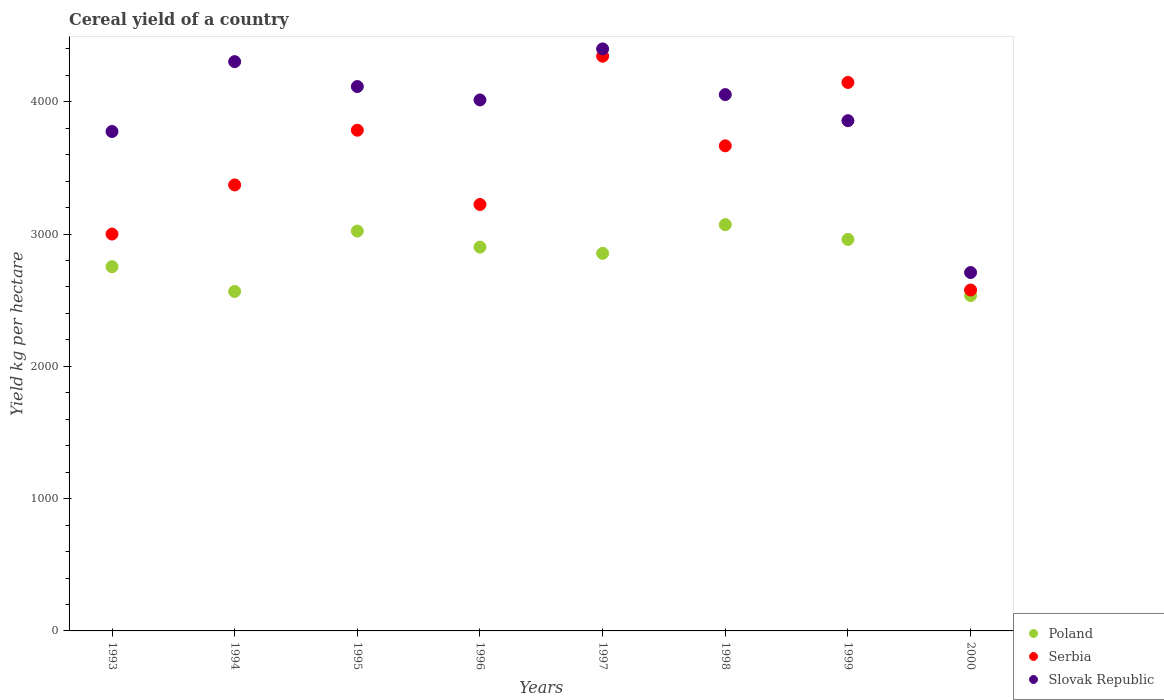How many different coloured dotlines are there?
Ensure brevity in your answer.  3. What is the total cereal yield in Poland in 1994?
Offer a terse response. 2566.15. Across all years, what is the maximum total cereal yield in Poland?
Provide a succinct answer. 3070.96. Across all years, what is the minimum total cereal yield in Serbia?
Your answer should be very brief. 2576.82. In which year was the total cereal yield in Poland maximum?
Your answer should be compact. 1998. In which year was the total cereal yield in Serbia minimum?
Provide a succinct answer. 2000. What is the total total cereal yield in Slovak Republic in the graph?
Your answer should be very brief. 3.12e+04. What is the difference between the total cereal yield in Slovak Republic in 1996 and that in 1998?
Provide a succinct answer. -40.36. What is the difference between the total cereal yield in Poland in 1993 and the total cereal yield in Serbia in 1995?
Offer a very short reply. -1031.81. What is the average total cereal yield in Serbia per year?
Give a very brief answer. 3514.04. In the year 1999, what is the difference between the total cereal yield in Slovak Republic and total cereal yield in Poland?
Keep it short and to the point. 897.32. What is the ratio of the total cereal yield in Slovak Republic in 1998 to that in 1999?
Ensure brevity in your answer.  1.05. Is the difference between the total cereal yield in Slovak Republic in 1993 and 2000 greater than the difference between the total cereal yield in Poland in 1993 and 2000?
Keep it short and to the point. Yes. What is the difference between the highest and the second highest total cereal yield in Serbia?
Make the answer very short. 198.02. What is the difference between the highest and the lowest total cereal yield in Slovak Republic?
Keep it short and to the point. 1690.08. Is the sum of the total cereal yield in Poland in 1995 and 1999 greater than the maximum total cereal yield in Serbia across all years?
Offer a very short reply. Yes. Is the total cereal yield in Serbia strictly less than the total cereal yield in Slovak Republic over the years?
Ensure brevity in your answer.  No. How many years are there in the graph?
Provide a short and direct response. 8. Does the graph contain any zero values?
Provide a succinct answer. No. What is the title of the graph?
Make the answer very short. Cereal yield of a country. What is the label or title of the X-axis?
Your answer should be very brief. Years. What is the label or title of the Y-axis?
Make the answer very short. Yield kg per hectare. What is the Yield kg per hectare in Poland in 1993?
Keep it short and to the point. 2752.95. What is the Yield kg per hectare of Serbia in 1993?
Your answer should be compact. 2999.79. What is the Yield kg per hectare of Slovak Republic in 1993?
Make the answer very short. 3774.97. What is the Yield kg per hectare in Poland in 1994?
Your answer should be compact. 2566.15. What is the Yield kg per hectare in Serbia in 1994?
Your response must be concise. 3371.02. What is the Yield kg per hectare of Slovak Republic in 1994?
Your response must be concise. 4302.99. What is the Yield kg per hectare in Poland in 1995?
Make the answer very short. 3022.36. What is the Yield kg per hectare in Serbia in 1995?
Make the answer very short. 3784.76. What is the Yield kg per hectare in Slovak Republic in 1995?
Keep it short and to the point. 4114.81. What is the Yield kg per hectare in Poland in 1996?
Provide a short and direct response. 2901.09. What is the Yield kg per hectare of Serbia in 1996?
Provide a succinct answer. 3223.3. What is the Yield kg per hectare of Slovak Republic in 1996?
Offer a very short reply. 4013.58. What is the Yield kg per hectare in Poland in 1997?
Keep it short and to the point. 2854.06. What is the Yield kg per hectare in Serbia in 1997?
Ensure brevity in your answer.  4343.93. What is the Yield kg per hectare of Slovak Republic in 1997?
Your response must be concise. 4399.25. What is the Yield kg per hectare in Poland in 1998?
Offer a terse response. 3070.96. What is the Yield kg per hectare of Serbia in 1998?
Offer a very short reply. 3666.8. What is the Yield kg per hectare in Slovak Republic in 1998?
Provide a short and direct response. 4053.93. What is the Yield kg per hectare of Poland in 1999?
Provide a succinct answer. 2959.36. What is the Yield kg per hectare in Serbia in 1999?
Offer a very short reply. 4145.9. What is the Yield kg per hectare in Slovak Republic in 1999?
Offer a very short reply. 3856.68. What is the Yield kg per hectare of Poland in 2000?
Ensure brevity in your answer.  2534.78. What is the Yield kg per hectare of Serbia in 2000?
Your response must be concise. 2576.82. What is the Yield kg per hectare in Slovak Republic in 2000?
Ensure brevity in your answer.  2709.16. Across all years, what is the maximum Yield kg per hectare of Poland?
Provide a short and direct response. 3070.96. Across all years, what is the maximum Yield kg per hectare in Serbia?
Your answer should be very brief. 4343.93. Across all years, what is the maximum Yield kg per hectare in Slovak Republic?
Provide a short and direct response. 4399.25. Across all years, what is the minimum Yield kg per hectare of Poland?
Provide a short and direct response. 2534.78. Across all years, what is the minimum Yield kg per hectare of Serbia?
Offer a terse response. 2576.82. Across all years, what is the minimum Yield kg per hectare of Slovak Republic?
Offer a terse response. 2709.16. What is the total Yield kg per hectare of Poland in the graph?
Your answer should be very brief. 2.27e+04. What is the total Yield kg per hectare in Serbia in the graph?
Make the answer very short. 2.81e+04. What is the total Yield kg per hectare in Slovak Republic in the graph?
Provide a succinct answer. 3.12e+04. What is the difference between the Yield kg per hectare of Poland in 1993 and that in 1994?
Your answer should be compact. 186.81. What is the difference between the Yield kg per hectare of Serbia in 1993 and that in 1994?
Offer a very short reply. -371.23. What is the difference between the Yield kg per hectare of Slovak Republic in 1993 and that in 1994?
Your answer should be very brief. -528.02. What is the difference between the Yield kg per hectare of Poland in 1993 and that in 1995?
Offer a very short reply. -269.41. What is the difference between the Yield kg per hectare in Serbia in 1993 and that in 1995?
Provide a short and direct response. -784.98. What is the difference between the Yield kg per hectare in Slovak Republic in 1993 and that in 1995?
Keep it short and to the point. -339.83. What is the difference between the Yield kg per hectare in Poland in 1993 and that in 1996?
Keep it short and to the point. -148.14. What is the difference between the Yield kg per hectare in Serbia in 1993 and that in 1996?
Your answer should be very brief. -223.51. What is the difference between the Yield kg per hectare in Slovak Republic in 1993 and that in 1996?
Keep it short and to the point. -238.6. What is the difference between the Yield kg per hectare of Poland in 1993 and that in 1997?
Provide a succinct answer. -101.11. What is the difference between the Yield kg per hectare of Serbia in 1993 and that in 1997?
Provide a succinct answer. -1344.14. What is the difference between the Yield kg per hectare in Slovak Republic in 1993 and that in 1997?
Make the answer very short. -624.27. What is the difference between the Yield kg per hectare of Poland in 1993 and that in 1998?
Offer a terse response. -318.01. What is the difference between the Yield kg per hectare in Serbia in 1993 and that in 1998?
Provide a short and direct response. -667.01. What is the difference between the Yield kg per hectare of Slovak Republic in 1993 and that in 1998?
Provide a short and direct response. -278.96. What is the difference between the Yield kg per hectare of Poland in 1993 and that in 1999?
Offer a very short reply. -206.41. What is the difference between the Yield kg per hectare of Serbia in 1993 and that in 1999?
Your response must be concise. -1146.12. What is the difference between the Yield kg per hectare in Slovak Republic in 1993 and that in 1999?
Offer a terse response. -81.71. What is the difference between the Yield kg per hectare in Poland in 1993 and that in 2000?
Ensure brevity in your answer.  218.17. What is the difference between the Yield kg per hectare of Serbia in 1993 and that in 2000?
Your answer should be compact. 422.96. What is the difference between the Yield kg per hectare in Slovak Republic in 1993 and that in 2000?
Keep it short and to the point. 1065.81. What is the difference between the Yield kg per hectare in Poland in 1994 and that in 1995?
Offer a terse response. -456.21. What is the difference between the Yield kg per hectare of Serbia in 1994 and that in 1995?
Make the answer very short. -413.74. What is the difference between the Yield kg per hectare in Slovak Republic in 1994 and that in 1995?
Your answer should be compact. 188.18. What is the difference between the Yield kg per hectare of Poland in 1994 and that in 1996?
Offer a terse response. -334.94. What is the difference between the Yield kg per hectare of Serbia in 1994 and that in 1996?
Offer a very short reply. 147.72. What is the difference between the Yield kg per hectare of Slovak Republic in 1994 and that in 1996?
Make the answer very short. 289.41. What is the difference between the Yield kg per hectare in Poland in 1994 and that in 1997?
Ensure brevity in your answer.  -287.92. What is the difference between the Yield kg per hectare in Serbia in 1994 and that in 1997?
Provide a succinct answer. -972.9. What is the difference between the Yield kg per hectare in Slovak Republic in 1994 and that in 1997?
Your answer should be compact. -96.26. What is the difference between the Yield kg per hectare of Poland in 1994 and that in 1998?
Keep it short and to the point. -504.81. What is the difference between the Yield kg per hectare in Serbia in 1994 and that in 1998?
Your response must be concise. -295.78. What is the difference between the Yield kg per hectare of Slovak Republic in 1994 and that in 1998?
Offer a terse response. 249.06. What is the difference between the Yield kg per hectare in Poland in 1994 and that in 1999?
Provide a short and direct response. -393.22. What is the difference between the Yield kg per hectare of Serbia in 1994 and that in 1999?
Offer a terse response. -774.88. What is the difference between the Yield kg per hectare in Slovak Republic in 1994 and that in 1999?
Your response must be concise. 446.31. What is the difference between the Yield kg per hectare of Poland in 1994 and that in 2000?
Your answer should be very brief. 31.37. What is the difference between the Yield kg per hectare of Serbia in 1994 and that in 2000?
Give a very brief answer. 794.2. What is the difference between the Yield kg per hectare in Slovak Republic in 1994 and that in 2000?
Make the answer very short. 1593.83. What is the difference between the Yield kg per hectare in Poland in 1995 and that in 1996?
Provide a succinct answer. 121.27. What is the difference between the Yield kg per hectare of Serbia in 1995 and that in 1996?
Ensure brevity in your answer.  561.46. What is the difference between the Yield kg per hectare in Slovak Republic in 1995 and that in 1996?
Provide a succinct answer. 101.23. What is the difference between the Yield kg per hectare of Poland in 1995 and that in 1997?
Your answer should be very brief. 168.3. What is the difference between the Yield kg per hectare of Serbia in 1995 and that in 1997?
Offer a very short reply. -559.16. What is the difference between the Yield kg per hectare of Slovak Republic in 1995 and that in 1997?
Offer a very short reply. -284.44. What is the difference between the Yield kg per hectare of Poland in 1995 and that in 1998?
Give a very brief answer. -48.6. What is the difference between the Yield kg per hectare of Serbia in 1995 and that in 1998?
Your response must be concise. 117.96. What is the difference between the Yield kg per hectare of Slovak Republic in 1995 and that in 1998?
Your response must be concise. 60.87. What is the difference between the Yield kg per hectare in Poland in 1995 and that in 1999?
Your answer should be very brief. 63. What is the difference between the Yield kg per hectare of Serbia in 1995 and that in 1999?
Your answer should be very brief. -361.14. What is the difference between the Yield kg per hectare of Slovak Republic in 1995 and that in 1999?
Your response must be concise. 258.13. What is the difference between the Yield kg per hectare in Poland in 1995 and that in 2000?
Your answer should be compact. 487.58. What is the difference between the Yield kg per hectare of Serbia in 1995 and that in 2000?
Offer a very short reply. 1207.94. What is the difference between the Yield kg per hectare in Slovak Republic in 1995 and that in 2000?
Ensure brevity in your answer.  1405.64. What is the difference between the Yield kg per hectare in Poland in 1996 and that in 1997?
Offer a very short reply. 47.03. What is the difference between the Yield kg per hectare of Serbia in 1996 and that in 1997?
Your answer should be very brief. -1120.62. What is the difference between the Yield kg per hectare of Slovak Republic in 1996 and that in 1997?
Make the answer very short. -385.67. What is the difference between the Yield kg per hectare of Poland in 1996 and that in 1998?
Your response must be concise. -169.87. What is the difference between the Yield kg per hectare of Serbia in 1996 and that in 1998?
Make the answer very short. -443.5. What is the difference between the Yield kg per hectare of Slovak Republic in 1996 and that in 1998?
Your response must be concise. -40.36. What is the difference between the Yield kg per hectare of Poland in 1996 and that in 1999?
Give a very brief answer. -58.27. What is the difference between the Yield kg per hectare in Serbia in 1996 and that in 1999?
Give a very brief answer. -922.6. What is the difference between the Yield kg per hectare in Slovak Republic in 1996 and that in 1999?
Give a very brief answer. 156.9. What is the difference between the Yield kg per hectare of Poland in 1996 and that in 2000?
Offer a very short reply. 366.31. What is the difference between the Yield kg per hectare of Serbia in 1996 and that in 2000?
Ensure brevity in your answer.  646.48. What is the difference between the Yield kg per hectare in Slovak Republic in 1996 and that in 2000?
Make the answer very short. 1304.41. What is the difference between the Yield kg per hectare of Poland in 1997 and that in 1998?
Your response must be concise. -216.9. What is the difference between the Yield kg per hectare of Serbia in 1997 and that in 1998?
Offer a very short reply. 677.12. What is the difference between the Yield kg per hectare in Slovak Republic in 1997 and that in 1998?
Keep it short and to the point. 345.31. What is the difference between the Yield kg per hectare of Poland in 1997 and that in 1999?
Make the answer very short. -105.3. What is the difference between the Yield kg per hectare of Serbia in 1997 and that in 1999?
Make the answer very short. 198.02. What is the difference between the Yield kg per hectare in Slovak Republic in 1997 and that in 1999?
Give a very brief answer. 542.57. What is the difference between the Yield kg per hectare of Poland in 1997 and that in 2000?
Make the answer very short. 319.28. What is the difference between the Yield kg per hectare of Serbia in 1997 and that in 2000?
Offer a very short reply. 1767.1. What is the difference between the Yield kg per hectare in Slovak Republic in 1997 and that in 2000?
Your answer should be compact. 1690.08. What is the difference between the Yield kg per hectare in Poland in 1998 and that in 1999?
Ensure brevity in your answer.  111.6. What is the difference between the Yield kg per hectare of Serbia in 1998 and that in 1999?
Ensure brevity in your answer.  -479.1. What is the difference between the Yield kg per hectare of Slovak Republic in 1998 and that in 1999?
Your response must be concise. 197.25. What is the difference between the Yield kg per hectare of Poland in 1998 and that in 2000?
Your answer should be compact. 536.18. What is the difference between the Yield kg per hectare of Serbia in 1998 and that in 2000?
Make the answer very short. 1089.98. What is the difference between the Yield kg per hectare of Slovak Republic in 1998 and that in 2000?
Your answer should be compact. 1344.77. What is the difference between the Yield kg per hectare of Poland in 1999 and that in 2000?
Provide a succinct answer. 424.58. What is the difference between the Yield kg per hectare in Serbia in 1999 and that in 2000?
Your answer should be compact. 1569.08. What is the difference between the Yield kg per hectare in Slovak Republic in 1999 and that in 2000?
Offer a terse response. 1147.52. What is the difference between the Yield kg per hectare in Poland in 1993 and the Yield kg per hectare in Serbia in 1994?
Provide a succinct answer. -618.07. What is the difference between the Yield kg per hectare in Poland in 1993 and the Yield kg per hectare in Slovak Republic in 1994?
Offer a very short reply. -1550.04. What is the difference between the Yield kg per hectare of Serbia in 1993 and the Yield kg per hectare of Slovak Republic in 1994?
Keep it short and to the point. -1303.2. What is the difference between the Yield kg per hectare of Poland in 1993 and the Yield kg per hectare of Serbia in 1995?
Offer a terse response. -1031.81. What is the difference between the Yield kg per hectare of Poland in 1993 and the Yield kg per hectare of Slovak Republic in 1995?
Offer a terse response. -1361.86. What is the difference between the Yield kg per hectare in Serbia in 1993 and the Yield kg per hectare in Slovak Republic in 1995?
Give a very brief answer. -1115.02. What is the difference between the Yield kg per hectare in Poland in 1993 and the Yield kg per hectare in Serbia in 1996?
Make the answer very short. -470.35. What is the difference between the Yield kg per hectare of Poland in 1993 and the Yield kg per hectare of Slovak Republic in 1996?
Keep it short and to the point. -1260.62. What is the difference between the Yield kg per hectare in Serbia in 1993 and the Yield kg per hectare in Slovak Republic in 1996?
Your answer should be compact. -1013.79. What is the difference between the Yield kg per hectare of Poland in 1993 and the Yield kg per hectare of Serbia in 1997?
Give a very brief answer. -1590.97. What is the difference between the Yield kg per hectare in Poland in 1993 and the Yield kg per hectare in Slovak Republic in 1997?
Your response must be concise. -1646.3. What is the difference between the Yield kg per hectare of Serbia in 1993 and the Yield kg per hectare of Slovak Republic in 1997?
Your response must be concise. -1399.46. What is the difference between the Yield kg per hectare of Poland in 1993 and the Yield kg per hectare of Serbia in 1998?
Your response must be concise. -913.85. What is the difference between the Yield kg per hectare of Poland in 1993 and the Yield kg per hectare of Slovak Republic in 1998?
Your response must be concise. -1300.98. What is the difference between the Yield kg per hectare in Serbia in 1993 and the Yield kg per hectare in Slovak Republic in 1998?
Offer a terse response. -1054.14. What is the difference between the Yield kg per hectare in Poland in 1993 and the Yield kg per hectare in Serbia in 1999?
Keep it short and to the point. -1392.95. What is the difference between the Yield kg per hectare of Poland in 1993 and the Yield kg per hectare of Slovak Republic in 1999?
Make the answer very short. -1103.73. What is the difference between the Yield kg per hectare in Serbia in 1993 and the Yield kg per hectare in Slovak Republic in 1999?
Your answer should be very brief. -856.89. What is the difference between the Yield kg per hectare of Poland in 1993 and the Yield kg per hectare of Serbia in 2000?
Your answer should be compact. 176.13. What is the difference between the Yield kg per hectare of Poland in 1993 and the Yield kg per hectare of Slovak Republic in 2000?
Your response must be concise. 43.79. What is the difference between the Yield kg per hectare in Serbia in 1993 and the Yield kg per hectare in Slovak Republic in 2000?
Your answer should be compact. 290.62. What is the difference between the Yield kg per hectare of Poland in 1994 and the Yield kg per hectare of Serbia in 1995?
Provide a short and direct response. -1218.62. What is the difference between the Yield kg per hectare in Poland in 1994 and the Yield kg per hectare in Slovak Republic in 1995?
Keep it short and to the point. -1548.66. What is the difference between the Yield kg per hectare of Serbia in 1994 and the Yield kg per hectare of Slovak Republic in 1995?
Keep it short and to the point. -743.78. What is the difference between the Yield kg per hectare of Poland in 1994 and the Yield kg per hectare of Serbia in 1996?
Your response must be concise. -657.15. What is the difference between the Yield kg per hectare of Poland in 1994 and the Yield kg per hectare of Slovak Republic in 1996?
Keep it short and to the point. -1447.43. What is the difference between the Yield kg per hectare in Serbia in 1994 and the Yield kg per hectare in Slovak Republic in 1996?
Provide a succinct answer. -642.55. What is the difference between the Yield kg per hectare of Poland in 1994 and the Yield kg per hectare of Serbia in 1997?
Keep it short and to the point. -1777.78. What is the difference between the Yield kg per hectare of Poland in 1994 and the Yield kg per hectare of Slovak Republic in 1997?
Provide a succinct answer. -1833.1. What is the difference between the Yield kg per hectare of Serbia in 1994 and the Yield kg per hectare of Slovak Republic in 1997?
Keep it short and to the point. -1028.22. What is the difference between the Yield kg per hectare of Poland in 1994 and the Yield kg per hectare of Serbia in 1998?
Offer a very short reply. -1100.65. What is the difference between the Yield kg per hectare in Poland in 1994 and the Yield kg per hectare in Slovak Republic in 1998?
Your answer should be compact. -1487.79. What is the difference between the Yield kg per hectare of Serbia in 1994 and the Yield kg per hectare of Slovak Republic in 1998?
Keep it short and to the point. -682.91. What is the difference between the Yield kg per hectare in Poland in 1994 and the Yield kg per hectare in Serbia in 1999?
Offer a terse response. -1579.76. What is the difference between the Yield kg per hectare of Poland in 1994 and the Yield kg per hectare of Slovak Republic in 1999?
Offer a terse response. -1290.53. What is the difference between the Yield kg per hectare of Serbia in 1994 and the Yield kg per hectare of Slovak Republic in 1999?
Offer a very short reply. -485.66. What is the difference between the Yield kg per hectare in Poland in 1994 and the Yield kg per hectare in Serbia in 2000?
Provide a succinct answer. -10.68. What is the difference between the Yield kg per hectare of Poland in 1994 and the Yield kg per hectare of Slovak Republic in 2000?
Your answer should be compact. -143.02. What is the difference between the Yield kg per hectare of Serbia in 1994 and the Yield kg per hectare of Slovak Republic in 2000?
Give a very brief answer. 661.86. What is the difference between the Yield kg per hectare in Poland in 1995 and the Yield kg per hectare in Serbia in 1996?
Offer a very short reply. -200.94. What is the difference between the Yield kg per hectare of Poland in 1995 and the Yield kg per hectare of Slovak Republic in 1996?
Your answer should be compact. -991.22. What is the difference between the Yield kg per hectare of Serbia in 1995 and the Yield kg per hectare of Slovak Republic in 1996?
Keep it short and to the point. -228.81. What is the difference between the Yield kg per hectare in Poland in 1995 and the Yield kg per hectare in Serbia in 1997?
Keep it short and to the point. -1321.56. What is the difference between the Yield kg per hectare of Poland in 1995 and the Yield kg per hectare of Slovak Republic in 1997?
Make the answer very short. -1376.88. What is the difference between the Yield kg per hectare of Serbia in 1995 and the Yield kg per hectare of Slovak Republic in 1997?
Offer a very short reply. -614.48. What is the difference between the Yield kg per hectare in Poland in 1995 and the Yield kg per hectare in Serbia in 1998?
Your response must be concise. -644.44. What is the difference between the Yield kg per hectare of Poland in 1995 and the Yield kg per hectare of Slovak Republic in 1998?
Offer a terse response. -1031.57. What is the difference between the Yield kg per hectare of Serbia in 1995 and the Yield kg per hectare of Slovak Republic in 1998?
Offer a very short reply. -269.17. What is the difference between the Yield kg per hectare in Poland in 1995 and the Yield kg per hectare in Serbia in 1999?
Your answer should be very brief. -1123.54. What is the difference between the Yield kg per hectare in Poland in 1995 and the Yield kg per hectare in Slovak Republic in 1999?
Offer a terse response. -834.32. What is the difference between the Yield kg per hectare in Serbia in 1995 and the Yield kg per hectare in Slovak Republic in 1999?
Your answer should be compact. -71.92. What is the difference between the Yield kg per hectare of Poland in 1995 and the Yield kg per hectare of Serbia in 2000?
Ensure brevity in your answer.  445.54. What is the difference between the Yield kg per hectare in Poland in 1995 and the Yield kg per hectare in Slovak Republic in 2000?
Provide a succinct answer. 313.2. What is the difference between the Yield kg per hectare of Serbia in 1995 and the Yield kg per hectare of Slovak Republic in 2000?
Your response must be concise. 1075.6. What is the difference between the Yield kg per hectare of Poland in 1996 and the Yield kg per hectare of Serbia in 1997?
Provide a succinct answer. -1442.84. What is the difference between the Yield kg per hectare in Poland in 1996 and the Yield kg per hectare in Slovak Republic in 1997?
Make the answer very short. -1498.16. What is the difference between the Yield kg per hectare in Serbia in 1996 and the Yield kg per hectare in Slovak Republic in 1997?
Your response must be concise. -1175.94. What is the difference between the Yield kg per hectare in Poland in 1996 and the Yield kg per hectare in Serbia in 1998?
Your answer should be very brief. -765.71. What is the difference between the Yield kg per hectare of Poland in 1996 and the Yield kg per hectare of Slovak Republic in 1998?
Make the answer very short. -1152.84. What is the difference between the Yield kg per hectare in Serbia in 1996 and the Yield kg per hectare in Slovak Republic in 1998?
Keep it short and to the point. -830.63. What is the difference between the Yield kg per hectare of Poland in 1996 and the Yield kg per hectare of Serbia in 1999?
Your answer should be compact. -1244.81. What is the difference between the Yield kg per hectare in Poland in 1996 and the Yield kg per hectare in Slovak Republic in 1999?
Make the answer very short. -955.59. What is the difference between the Yield kg per hectare in Serbia in 1996 and the Yield kg per hectare in Slovak Republic in 1999?
Offer a very short reply. -633.38. What is the difference between the Yield kg per hectare of Poland in 1996 and the Yield kg per hectare of Serbia in 2000?
Offer a very short reply. 324.27. What is the difference between the Yield kg per hectare in Poland in 1996 and the Yield kg per hectare in Slovak Republic in 2000?
Offer a very short reply. 191.93. What is the difference between the Yield kg per hectare in Serbia in 1996 and the Yield kg per hectare in Slovak Republic in 2000?
Offer a terse response. 514.14. What is the difference between the Yield kg per hectare of Poland in 1997 and the Yield kg per hectare of Serbia in 1998?
Your answer should be very brief. -812.74. What is the difference between the Yield kg per hectare in Poland in 1997 and the Yield kg per hectare in Slovak Republic in 1998?
Keep it short and to the point. -1199.87. What is the difference between the Yield kg per hectare of Serbia in 1997 and the Yield kg per hectare of Slovak Republic in 1998?
Provide a short and direct response. 289.99. What is the difference between the Yield kg per hectare of Poland in 1997 and the Yield kg per hectare of Serbia in 1999?
Provide a short and direct response. -1291.84. What is the difference between the Yield kg per hectare of Poland in 1997 and the Yield kg per hectare of Slovak Republic in 1999?
Keep it short and to the point. -1002.62. What is the difference between the Yield kg per hectare in Serbia in 1997 and the Yield kg per hectare in Slovak Republic in 1999?
Offer a terse response. 487.25. What is the difference between the Yield kg per hectare in Poland in 1997 and the Yield kg per hectare in Serbia in 2000?
Keep it short and to the point. 277.24. What is the difference between the Yield kg per hectare in Poland in 1997 and the Yield kg per hectare in Slovak Republic in 2000?
Offer a terse response. 144.9. What is the difference between the Yield kg per hectare in Serbia in 1997 and the Yield kg per hectare in Slovak Republic in 2000?
Give a very brief answer. 1634.76. What is the difference between the Yield kg per hectare of Poland in 1998 and the Yield kg per hectare of Serbia in 1999?
Keep it short and to the point. -1074.94. What is the difference between the Yield kg per hectare of Poland in 1998 and the Yield kg per hectare of Slovak Republic in 1999?
Your answer should be very brief. -785.72. What is the difference between the Yield kg per hectare of Serbia in 1998 and the Yield kg per hectare of Slovak Republic in 1999?
Make the answer very short. -189.88. What is the difference between the Yield kg per hectare of Poland in 1998 and the Yield kg per hectare of Serbia in 2000?
Provide a succinct answer. 494.14. What is the difference between the Yield kg per hectare of Poland in 1998 and the Yield kg per hectare of Slovak Republic in 2000?
Offer a very short reply. 361.8. What is the difference between the Yield kg per hectare of Serbia in 1998 and the Yield kg per hectare of Slovak Republic in 2000?
Ensure brevity in your answer.  957.64. What is the difference between the Yield kg per hectare of Poland in 1999 and the Yield kg per hectare of Serbia in 2000?
Offer a very short reply. 382.54. What is the difference between the Yield kg per hectare of Poland in 1999 and the Yield kg per hectare of Slovak Republic in 2000?
Give a very brief answer. 250.2. What is the difference between the Yield kg per hectare of Serbia in 1999 and the Yield kg per hectare of Slovak Republic in 2000?
Your answer should be very brief. 1436.74. What is the average Yield kg per hectare of Poland per year?
Give a very brief answer. 2832.72. What is the average Yield kg per hectare in Serbia per year?
Provide a short and direct response. 3514.04. What is the average Yield kg per hectare in Slovak Republic per year?
Make the answer very short. 3903.17. In the year 1993, what is the difference between the Yield kg per hectare in Poland and Yield kg per hectare in Serbia?
Provide a succinct answer. -246.84. In the year 1993, what is the difference between the Yield kg per hectare of Poland and Yield kg per hectare of Slovak Republic?
Your answer should be compact. -1022.02. In the year 1993, what is the difference between the Yield kg per hectare in Serbia and Yield kg per hectare in Slovak Republic?
Your response must be concise. -775.18. In the year 1994, what is the difference between the Yield kg per hectare of Poland and Yield kg per hectare of Serbia?
Your answer should be compact. -804.88. In the year 1994, what is the difference between the Yield kg per hectare in Poland and Yield kg per hectare in Slovak Republic?
Offer a very short reply. -1736.84. In the year 1994, what is the difference between the Yield kg per hectare of Serbia and Yield kg per hectare of Slovak Republic?
Offer a very short reply. -931.97. In the year 1995, what is the difference between the Yield kg per hectare of Poland and Yield kg per hectare of Serbia?
Provide a short and direct response. -762.4. In the year 1995, what is the difference between the Yield kg per hectare of Poland and Yield kg per hectare of Slovak Republic?
Give a very brief answer. -1092.44. In the year 1995, what is the difference between the Yield kg per hectare in Serbia and Yield kg per hectare in Slovak Republic?
Keep it short and to the point. -330.04. In the year 1996, what is the difference between the Yield kg per hectare of Poland and Yield kg per hectare of Serbia?
Make the answer very short. -322.21. In the year 1996, what is the difference between the Yield kg per hectare in Poland and Yield kg per hectare in Slovak Republic?
Your answer should be very brief. -1112.49. In the year 1996, what is the difference between the Yield kg per hectare of Serbia and Yield kg per hectare of Slovak Republic?
Provide a succinct answer. -790.27. In the year 1997, what is the difference between the Yield kg per hectare in Poland and Yield kg per hectare in Serbia?
Provide a succinct answer. -1489.86. In the year 1997, what is the difference between the Yield kg per hectare in Poland and Yield kg per hectare in Slovak Republic?
Your answer should be compact. -1545.18. In the year 1997, what is the difference between the Yield kg per hectare in Serbia and Yield kg per hectare in Slovak Republic?
Your answer should be very brief. -55.32. In the year 1998, what is the difference between the Yield kg per hectare in Poland and Yield kg per hectare in Serbia?
Your answer should be very brief. -595.84. In the year 1998, what is the difference between the Yield kg per hectare of Poland and Yield kg per hectare of Slovak Republic?
Give a very brief answer. -982.97. In the year 1998, what is the difference between the Yield kg per hectare of Serbia and Yield kg per hectare of Slovak Republic?
Provide a short and direct response. -387.13. In the year 1999, what is the difference between the Yield kg per hectare in Poland and Yield kg per hectare in Serbia?
Your response must be concise. -1186.54. In the year 1999, what is the difference between the Yield kg per hectare in Poland and Yield kg per hectare in Slovak Republic?
Your answer should be very brief. -897.32. In the year 1999, what is the difference between the Yield kg per hectare in Serbia and Yield kg per hectare in Slovak Republic?
Provide a succinct answer. 289.22. In the year 2000, what is the difference between the Yield kg per hectare of Poland and Yield kg per hectare of Serbia?
Give a very brief answer. -42.04. In the year 2000, what is the difference between the Yield kg per hectare of Poland and Yield kg per hectare of Slovak Republic?
Provide a succinct answer. -174.38. In the year 2000, what is the difference between the Yield kg per hectare in Serbia and Yield kg per hectare in Slovak Republic?
Make the answer very short. -132.34. What is the ratio of the Yield kg per hectare in Poland in 1993 to that in 1994?
Ensure brevity in your answer.  1.07. What is the ratio of the Yield kg per hectare in Serbia in 1993 to that in 1994?
Offer a very short reply. 0.89. What is the ratio of the Yield kg per hectare in Slovak Republic in 1993 to that in 1994?
Make the answer very short. 0.88. What is the ratio of the Yield kg per hectare in Poland in 1993 to that in 1995?
Give a very brief answer. 0.91. What is the ratio of the Yield kg per hectare in Serbia in 1993 to that in 1995?
Your response must be concise. 0.79. What is the ratio of the Yield kg per hectare of Slovak Republic in 1993 to that in 1995?
Keep it short and to the point. 0.92. What is the ratio of the Yield kg per hectare of Poland in 1993 to that in 1996?
Offer a very short reply. 0.95. What is the ratio of the Yield kg per hectare in Serbia in 1993 to that in 1996?
Give a very brief answer. 0.93. What is the ratio of the Yield kg per hectare of Slovak Republic in 1993 to that in 1996?
Offer a very short reply. 0.94. What is the ratio of the Yield kg per hectare of Poland in 1993 to that in 1997?
Provide a succinct answer. 0.96. What is the ratio of the Yield kg per hectare in Serbia in 1993 to that in 1997?
Your answer should be compact. 0.69. What is the ratio of the Yield kg per hectare of Slovak Republic in 1993 to that in 1997?
Your answer should be compact. 0.86. What is the ratio of the Yield kg per hectare of Poland in 1993 to that in 1998?
Keep it short and to the point. 0.9. What is the ratio of the Yield kg per hectare in Serbia in 1993 to that in 1998?
Your response must be concise. 0.82. What is the ratio of the Yield kg per hectare in Slovak Republic in 1993 to that in 1998?
Your answer should be very brief. 0.93. What is the ratio of the Yield kg per hectare in Poland in 1993 to that in 1999?
Make the answer very short. 0.93. What is the ratio of the Yield kg per hectare of Serbia in 1993 to that in 1999?
Provide a short and direct response. 0.72. What is the ratio of the Yield kg per hectare in Slovak Republic in 1993 to that in 1999?
Keep it short and to the point. 0.98. What is the ratio of the Yield kg per hectare of Poland in 1993 to that in 2000?
Provide a succinct answer. 1.09. What is the ratio of the Yield kg per hectare in Serbia in 1993 to that in 2000?
Ensure brevity in your answer.  1.16. What is the ratio of the Yield kg per hectare of Slovak Republic in 1993 to that in 2000?
Your response must be concise. 1.39. What is the ratio of the Yield kg per hectare of Poland in 1994 to that in 1995?
Offer a terse response. 0.85. What is the ratio of the Yield kg per hectare of Serbia in 1994 to that in 1995?
Provide a succinct answer. 0.89. What is the ratio of the Yield kg per hectare of Slovak Republic in 1994 to that in 1995?
Keep it short and to the point. 1.05. What is the ratio of the Yield kg per hectare of Poland in 1994 to that in 1996?
Give a very brief answer. 0.88. What is the ratio of the Yield kg per hectare in Serbia in 1994 to that in 1996?
Keep it short and to the point. 1.05. What is the ratio of the Yield kg per hectare in Slovak Republic in 1994 to that in 1996?
Keep it short and to the point. 1.07. What is the ratio of the Yield kg per hectare of Poland in 1994 to that in 1997?
Offer a terse response. 0.9. What is the ratio of the Yield kg per hectare of Serbia in 1994 to that in 1997?
Make the answer very short. 0.78. What is the ratio of the Yield kg per hectare in Slovak Republic in 1994 to that in 1997?
Keep it short and to the point. 0.98. What is the ratio of the Yield kg per hectare in Poland in 1994 to that in 1998?
Your answer should be very brief. 0.84. What is the ratio of the Yield kg per hectare in Serbia in 1994 to that in 1998?
Give a very brief answer. 0.92. What is the ratio of the Yield kg per hectare of Slovak Republic in 1994 to that in 1998?
Give a very brief answer. 1.06. What is the ratio of the Yield kg per hectare in Poland in 1994 to that in 1999?
Your answer should be compact. 0.87. What is the ratio of the Yield kg per hectare of Serbia in 1994 to that in 1999?
Ensure brevity in your answer.  0.81. What is the ratio of the Yield kg per hectare of Slovak Republic in 1994 to that in 1999?
Your answer should be compact. 1.12. What is the ratio of the Yield kg per hectare in Poland in 1994 to that in 2000?
Provide a short and direct response. 1.01. What is the ratio of the Yield kg per hectare of Serbia in 1994 to that in 2000?
Keep it short and to the point. 1.31. What is the ratio of the Yield kg per hectare in Slovak Republic in 1994 to that in 2000?
Offer a very short reply. 1.59. What is the ratio of the Yield kg per hectare of Poland in 1995 to that in 1996?
Make the answer very short. 1.04. What is the ratio of the Yield kg per hectare in Serbia in 1995 to that in 1996?
Offer a very short reply. 1.17. What is the ratio of the Yield kg per hectare of Slovak Republic in 1995 to that in 1996?
Provide a short and direct response. 1.03. What is the ratio of the Yield kg per hectare in Poland in 1995 to that in 1997?
Your answer should be compact. 1.06. What is the ratio of the Yield kg per hectare of Serbia in 1995 to that in 1997?
Offer a very short reply. 0.87. What is the ratio of the Yield kg per hectare of Slovak Republic in 1995 to that in 1997?
Offer a very short reply. 0.94. What is the ratio of the Yield kg per hectare of Poland in 1995 to that in 1998?
Keep it short and to the point. 0.98. What is the ratio of the Yield kg per hectare of Serbia in 1995 to that in 1998?
Ensure brevity in your answer.  1.03. What is the ratio of the Yield kg per hectare of Slovak Republic in 1995 to that in 1998?
Keep it short and to the point. 1.01. What is the ratio of the Yield kg per hectare in Poland in 1995 to that in 1999?
Make the answer very short. 1.02. What is the ratio of the Yield kg per hectare of Serbia in 1995 to that in 1999?
Provide a succinct answer. 0.91. What is the ratio of the Yield kg per hectare in Slovak Republic in 1995 to that in 1999?
Provide a succinct answer. 1.07. What is the ratio of the Yield kg per hectare in Poland in 1995 to that in 2000?
Give a very brief answer. 1.19. What is the ratio of the Yield kg per hectare in Serbia in 1995 to that in 2000?
Give a very brief answer. 1.47. What is the ratio of the Yield kg per hectare in Slovak Republic in 1995 to that in 2000?
Offer a terse response. 1.52. What is the ratio of the Yield kg per hectare of Poland in 1996 to that in 1997?
Your answer should be compact. 1.02. What is the ratio of the Yield kg per hectare in Serbia in 1996 to that in 1997?
Provide a short and direct response. 0.74. What is the ratio of the Yield kg per hectare of Slovak Republic in 1996 to that in 1997?
Your answer should be very brief. 0.91. What is the ratio of the Yield kg per hectare in Poland in 1996 to that in 1998?
Offer a very short reply. 0.94. What is the ratio of the Yield kg per hectare in Serbia in 1996 to that in 1998?
Ensure brevity in your answer.  0.88. What is the ratio of the Yield kg per hectare in Slovak Republic in 1996 to that in 1998?
Offer a very short reply. 0.99. What is the ratio of the Yield kg per hectare in Poland in 1996 to that in 1999?
Your answer should be compact. 0.98. What is the ratio of the Yield kg per hectare in Serbia in 1996 to that in 1999?
Ensure brevity in your answer.  0.78. What is the ratio of the Yield kg per hectare in Slovak Republic in 1996 to that in 1999?
Keep it short and to the point. 1.04. What is the ratio of the Yield kg per hectare of Poland in 1996 to that in 2000?
Your response must be concise. 1.14. What is the ratio of the Yield kg per hectare of Serbia in 1996 to that in 2000?
Your response must be concise. 1.25. What is the ratio of the Yield kg per hectare in Slovak Republic in 1996 to that in 2000?
Ensure brevity in your answer.  1.48. What is the ratio of the Yield kg per hectare in Poland in 1997 to that in 1998?
Your response must be concise. 0.93. What is the ratio of the Yield kg per hectare of Serbia in 1997 to that in 1998?
Offer a very short reply. 1.18. What is the ratio of the Yield kg per hectare of Slovak Republic in 1997 to that in 1998?
Offer a very short reply. 1.09. What is the ratio of the Yield kg per hectare of Poland in 1997 to that in 1999?
Offer a terse response. 0.96. What is the ratio of the Yield kg per hectare in Serbia in 1997 to that in 1999?
Your answer should be very brief. 1.05. What is the ratio of the Yield kg per hectare of Slovak Republic in 1997 to that in 1999?
Make the answer very short. 1.14. What is the ratio of the Yield kg per hectare of Poland in 1997 to that in 2000?
Your response must be concise. 1.13. What is the ratio of the Yield kg per hectare of Serbia in 1997 to that in 2000?
Make the answer very short. 1.69. What is the ratio of the Yield kg per hectare in Slovak Republic in 1997 to that in 2000?
Offer a very short reply. 1.62. What is the ratio of the Yield kg per hectare in Poland in 1998 to that in 1999?
Offer a terse response. 1.04. What is the ratio of the Yield kg per hectare of Serbia in 1998 to that in 1999?
Offer a terse response. 0.88. What is the ratio of the Yield kg per hectare in Slovak Republic in 1998 to that in 1999?
Provide a short and direct response. 1.05. What is the ratio of the Yield kg per hectare of Poland in 1998 to that in 2000?
Give a very brief answer. 1.21. What is the ratio of the Yield kg per hectare of Serbia in 1998 to that in 2000?
Give a very brief answer. 1.42. What is the ratio of the Yield kg per hectare of Slovak Republic in 1998 to that in 2000?
Your answer should be compact. 1.5. What is the ratio of the Yield kg per hectare in Poland in 1999 to that in 2000?
Ensure brevity in your answer.  1.17. What is the ratio of the Yield kg per hectare in Serbia in 1999 to that in 2000?
Your answer should be very brief. 1.61. What is the ratio of the Yield kg per hectare in Slovak Republic in 1999 to that in 2000?
Offer a terse response. 1.42. What is the difference between the highest and the second highest Yield kg per hectare in Poland?
Your answer should be compact. 48.6. What is the difference between the highest and the second highest Yield kg per hectare of Serbia?
Your answer should be very brief. 198.02. What is the difference between the highest and the second highest Yield kg per hectare in Slovak Republic?
Make the answer very short. 96.26. What is the difference between the highest and the lowest Yield kg per hectare of Poland?
Ensure brevity in your answer.  536.18. What is the difference between the highest and the lowest Yield kg per hectare in Serbia?
Give a very brief answer. 1767.1. What is the difference between the highest and the lowest Yield kg per hectare in Slovak Republic?
Your answer should be compact. 1690.08. 